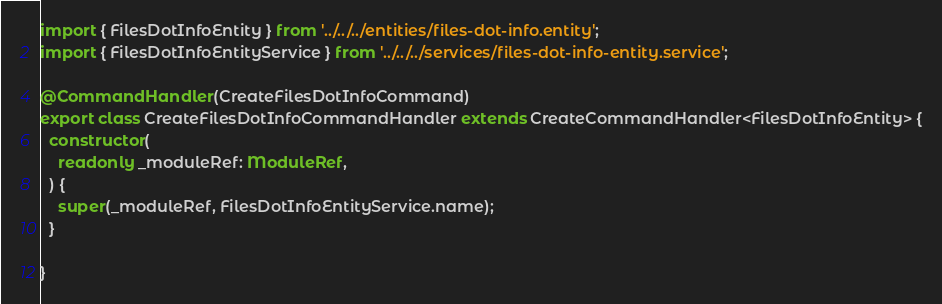<code> <loc_0><loc_0><loc_500><loc_500><_TypeScript_>import { FilesDotInfoEntity } from '../../../entities/files-dot-info.entity';
import { FilesDotInfoEntityService } from '../../../services/files-dot-info-entity.service';

@CommandHandler(CreateFilesDotInfoCommand)
export class CreateFilesDotInfoCommandHandler extends CreateCommandHandler<FilesDotInfoEntity> {
  constructor(
    readonly _moduleRef: ModuleRef,
  ) {
    super(_moduleRef, FilesDotInfoEntityService.name);
  }

}
</code> 